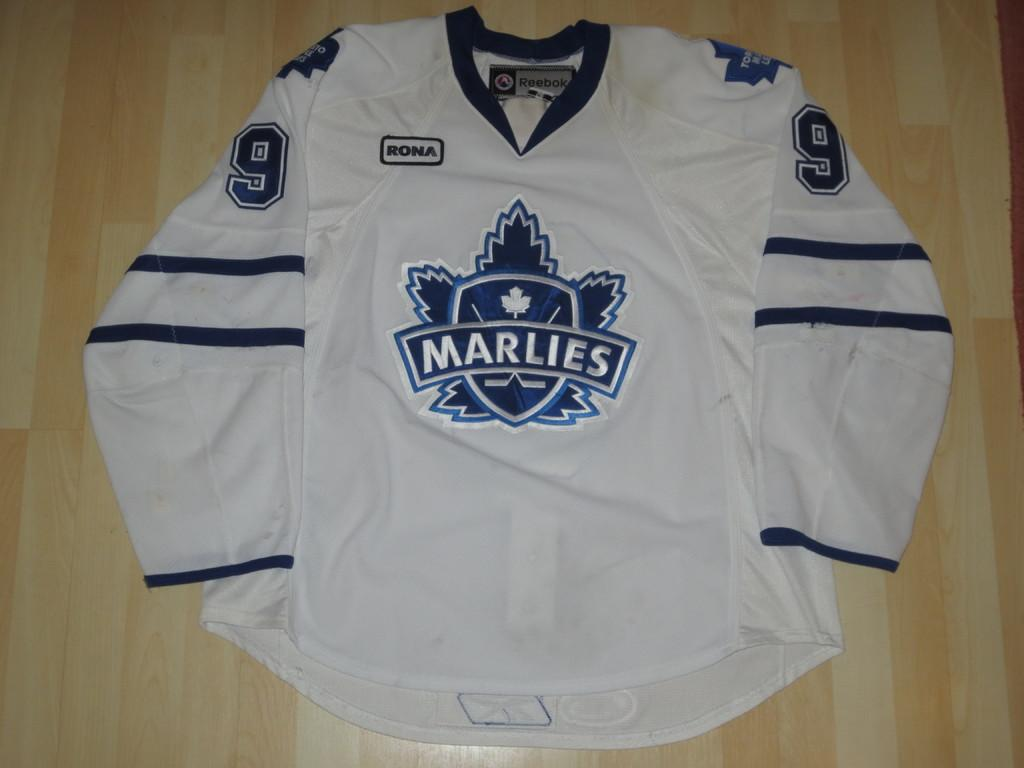<image>
Create a compact narrative representing the image presented. white and blue #9 jersey for the marlies on wooden surface 